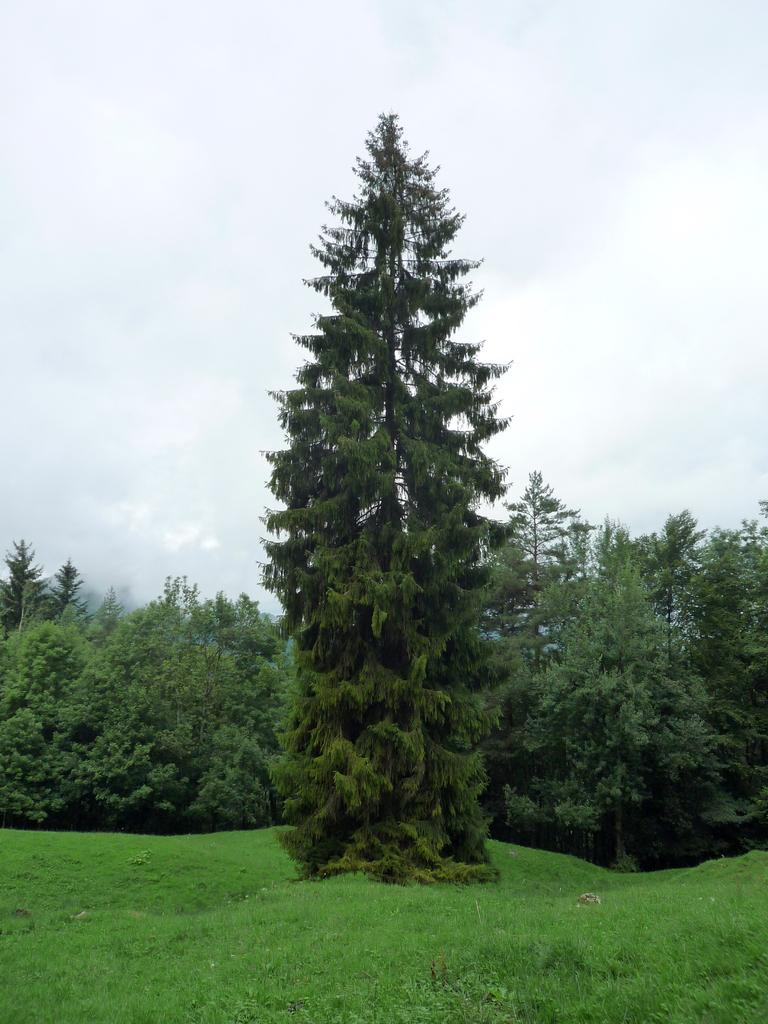What type of vegetation can be seen in the image? There are trees in the image. What is visible at the bottom of the image? There is ground visible at the bottom of the image. What can be seen in the sky at the top of the image? Clouds are present in the sky at the top of the image. What type of bomb is present in the image? There is no bomb present in the image. Can you describe the muscles of the trees in the image? Trees do not have muscles, as they are plants and not animals. 